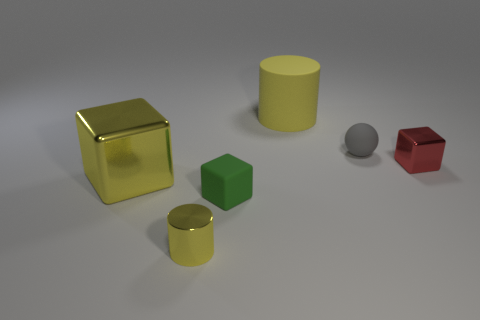Subtract all red metallic blocks. How many blocks are left? 2 Subtract all cylinders. How many objects are left? 4 Subtract all green blocks. How many blocks are left? 2 Subtract 0 yellow balls. How many objects are left? 6 Subtract 2 cubes. How many cubes are left? 1 Subtract all gray cubes. Subtract all gray cylinders. How many cubes are left? 3 Subtract all purple spheres. How many green cylinders are left? 0 Subtract all small gray things. Subtract all metallic cylinders. How many objects are left? 4 Add 1 tiny red shiny objects. How many tiny red shiny objects are left? 2 Add 3 tiny red metallic blocks. How many tiny red metallic blocks exist? 4 